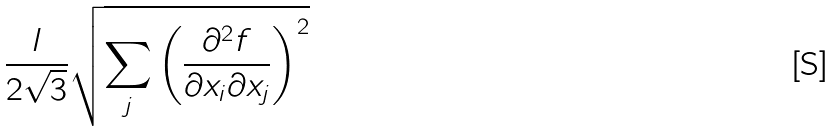Convert formula to latex. <formula><loc_0><loc_0><loc_500><loc_500>\frac { l } { 2 \sqrt { 3 } } \sqrt { \sum _ { j } \left ( \frac { \partial ^ { 2 } f } { \partial x _ { i } \partial x _ { j } } \right ) ^ { 2 } }</formula> 